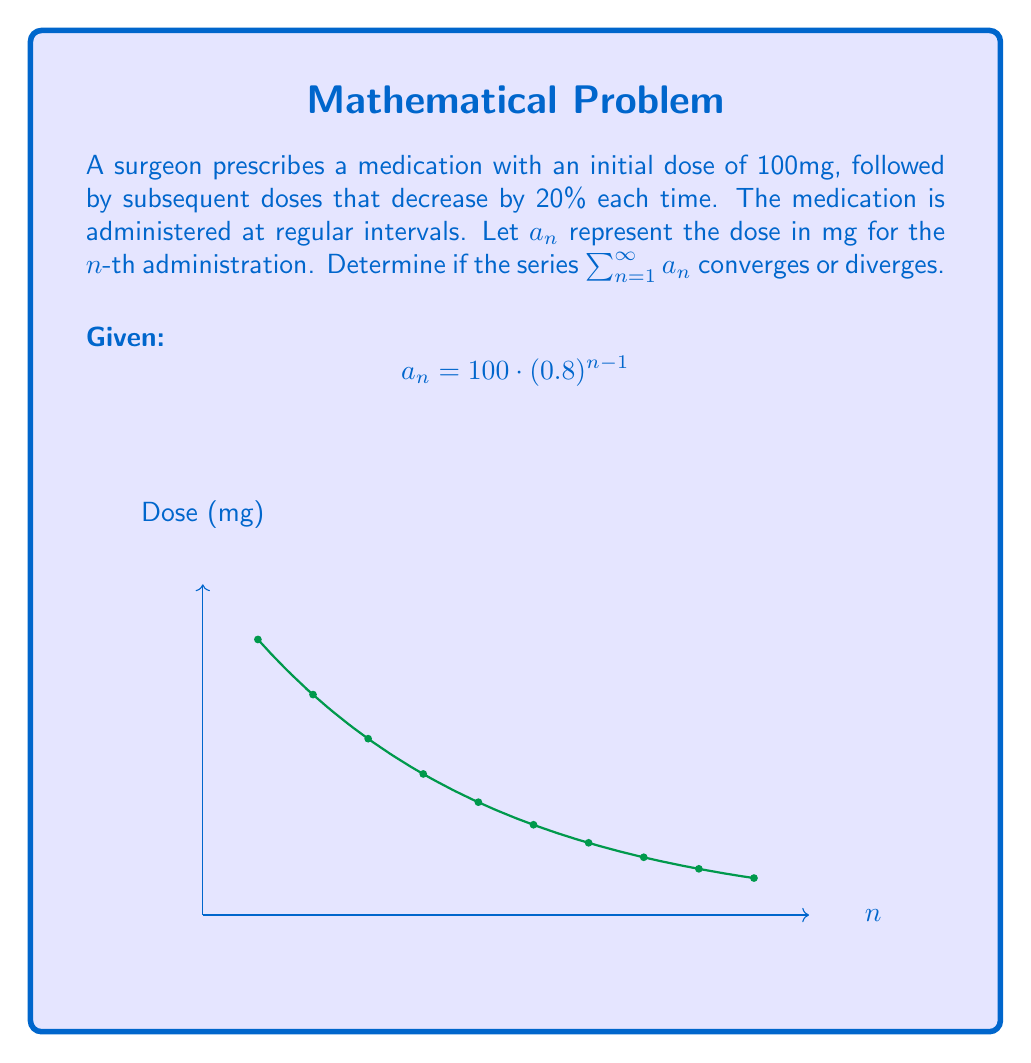Could you help me with this problem? To analyze the convergence of this series, we'll use the ratio test:

1) First, let's write out the general term of the series:
   $$a_n = 100 \cdot (0.8)^{n-1}$$

2) Now, we'll form the ratio of successive terms:
   $$\lim_{n \to \infty} \left|\frac{a_{n+1}}{a_n}\right| = \lim_{n \to \infty} \left|\frac{100 \cdot (0.8)^n}{100 \cdot (0.8)^{n-1}}\right|$$

3) Simplify:
   $$\lim_{n \to \infty} \left|\frac{100 \cdot (0.8)^n}{100 \cdot (0.8)^{n-1}}\right| = \lim_{n \to \infty} |0.8|$$

4) Evaluate the limit:
   $$\lim_{n \to \infty} |0.8| = 0.8$$

5) Since the limit is less than 1, the ratio test tells us that the series converges.

6) We can interpret this medically: The total amount of medication administered over an infinite number of doses is finite, which is important for understanding long-term exposure and potential cumulative effects.
Answer: The series converges (ratio test: $\lim_{n \to \infty} \left|\frac{a_{n+1}}{a_n}\right| = 0.8 < 1$). 